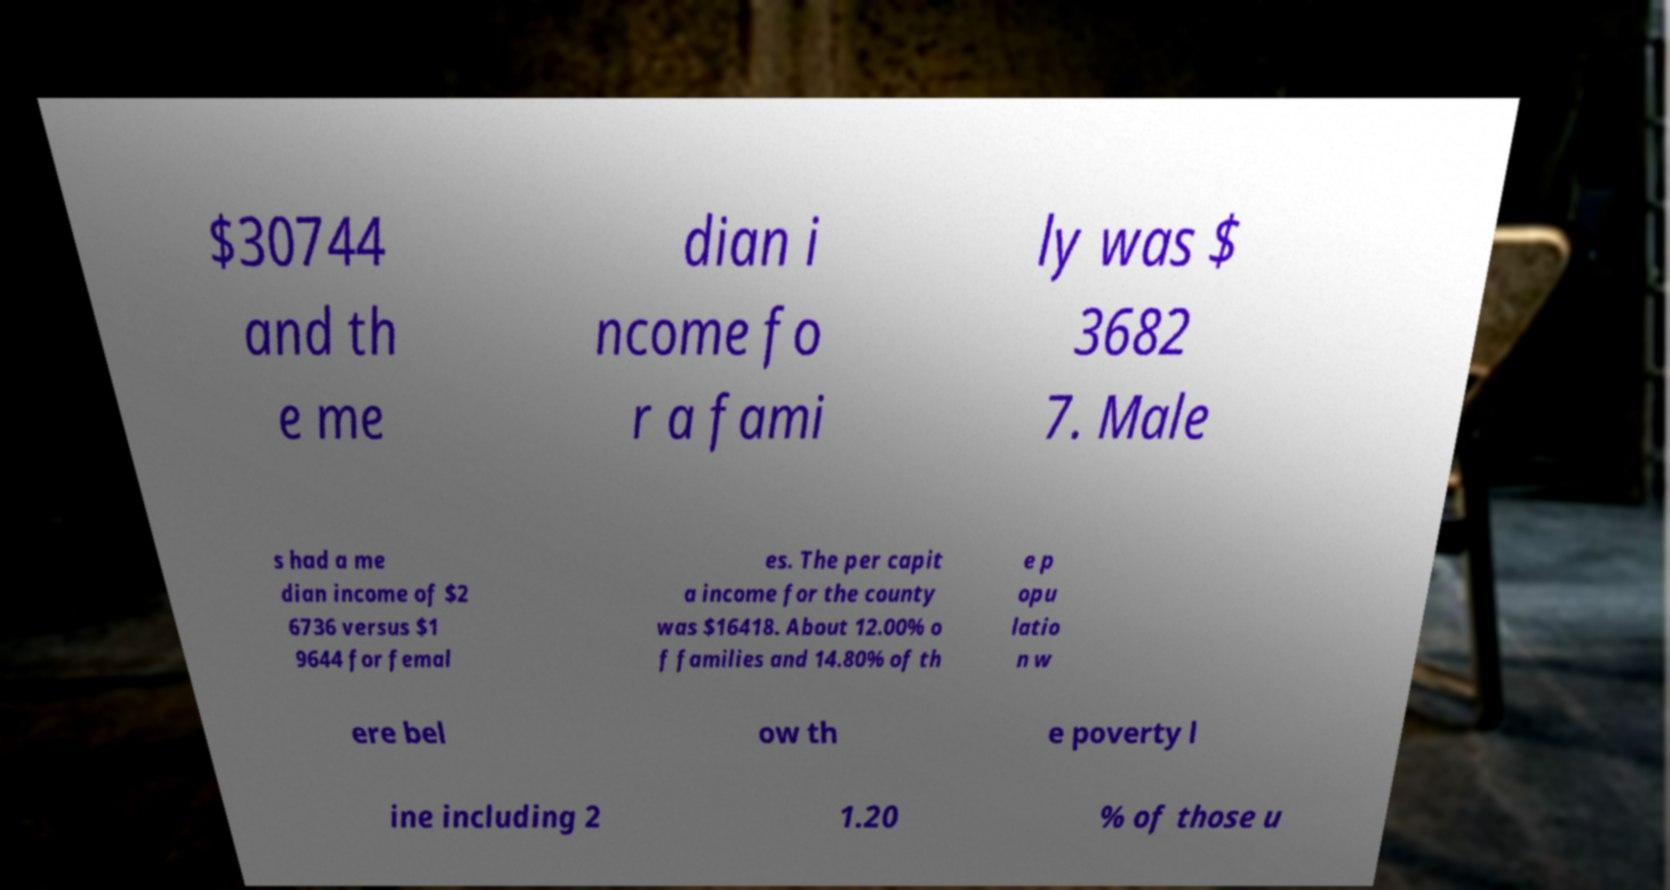Could you assist in decoding the text presented in this image and type it out clearly? $30744 and th e me dian i ncome fo r a fami ly was $ 3682 7. Male s had a me dian income of $2 6736 versus $1 9644 for femal es. The per capit a income for the county was $16418. About 12.00% o f families and 14.80% of th e p opu latio n w ere bel ow th e poverty l ine including 2 1.20 % of those u 